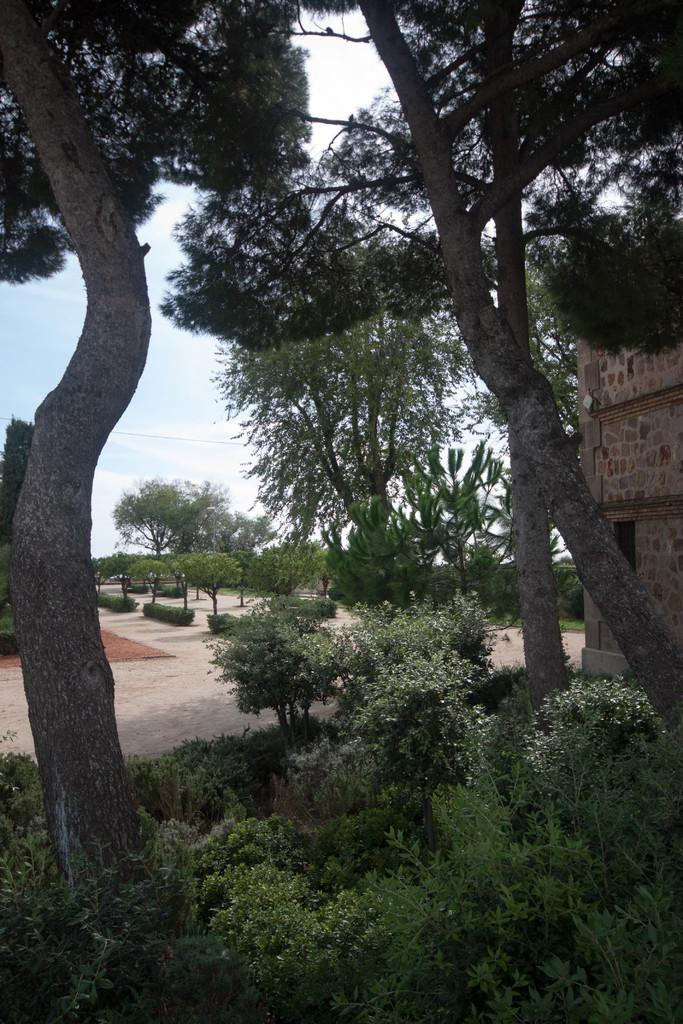What type of vegetation can be seen in the image? There are trees in the image. What area is visible in the image? There is a garden in the image. Where is the house located in the image? The house is on the right side of the image. What is visible in the background of the image? The sky is visible in the background of the image. What is the condition of the sky in the image? The sky is clear in the image. What type of religion is practiced in the garden in the image? There is no indication of any religious practice in the image; it simply shows a garden with trees and a house. How many clocks are visible in the image? There are no clocks present in the image. 